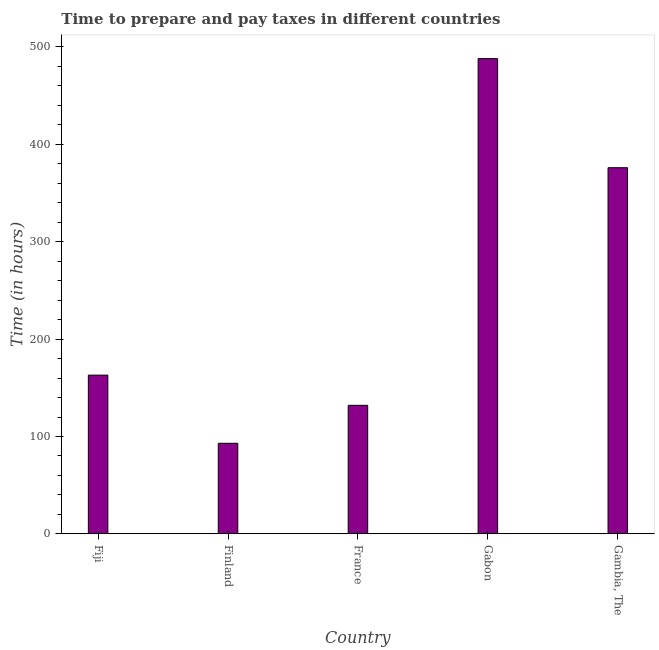Does the graph contain any zero values?
Provide a succinct answer. No. What is the title of the graph?
Provide a succinct answer. Time to prepare and pay taxes in different countries. What is the label or title of the X-axis?
Ensure brevity in your answer.  Country. What is the label or title of the Y-axis?
Your answer should be very brief. Time (in hours). What is the time to prepare and pay taxes in Fiji?
Give a very brief answer. 163. Across all countries, what is the maximum time to prepare and pay taxes?
Offer a very short reply. 488. Across all countries, what is the minimum time to prepare and pay taxes?
Keep it short and to the point. 93. In which country was the time to prepare and pay taxes maximum?
Your response must be concise. Gabon. What is the sum of the time to prepare and pay taxes?
Your answer should be very brief. 1252. What is the difference between the time to prepare and pay taxes in Finland and France?
Your answer should be very brief. -39. What is the average time to prepare and pay taxes per country?
Provide a succinct answer. 250.4. What is the median time to prepare and pay taxes?
Your answer should be very brief. 163. In how many countries, is the time to prepare and pay taxes greater than 100 hours?
Your answer should be very brief. 4. What is the ratio of the time to prepare and pay taxes in Gabon to that in Gambia, The?
Give a very brief answer. 1.3. Is the time to prepare and pay taxes in Fiji less than that in Gabon?
Keep it short and to the point. Yes. Is the difference between the time to prepare and pay taxes in France and Gabon greater than the difference between any two countries?
Offer a very short reply. No. What is the difference between the highest and the second highest time to prepare and pay taxes?
Make the answer very short. 112. Is the sum of the time to prepare and pay taxes in Finland and France greater than the maximum time to prepare and pay taxes across all countries?
Give a very brief answer. No. What is the difference between the highest and the lowest time to prepare and pay taxes?
Your answer should be very brief. 395. In how many countries, is the time to prepare and pay taxes greater than the average time to prepare and pay taxes taken over all countries?
Make the answer very short. 2. How many bars are there?
Provide a short and direct response. 5. How many countries are there in the graph?
Offer a very short reply. 5. What is the difference between two consecutive major ticks on the Y-axis?
Keep it short and to the point. 100. What is the Time (in hours) of Fiji?
Your answer should be compact. 163. What is the Time (in hours) of Finland?
Your answer should be compact. 93. What is the Time (in hours) in France?
Offer a terse response. 132. What is the Time (in hours) in Gabon?
Your answer should be very brief. 488. What is the Time (in hours) of Gambia, The?
Your answer should be compact. 376. What is the difference between the Time (in hours) in Fiji and France?
Provide a succinct answer. 31. What is the difference between the Time (in hours) in Fiji and Gabon?
Provide a succinct answer. -325. What is the difference between the Time (in hours) in Fiji and Gambia, The?
Ensure brevity in your answer.  -213. What is the difference between the Time (in hours) in Finland and France?
Provide a succinct answer. -39. What is the difference between the Time (in hours) in Finland and Gabon?
Ensure brevity in your answer.  -395. What is the difference between the Time (in hours) in Finland and Gambia, The?
Your response must be concise. -283. What is the difference between the Time (in hours) in France and Gabon?
Your answer should be compact. -356. What is the difference between the Time (in hours) in France and Gambia, The?
Your response must be concise. -244. What is the difference between the Time (in hours) in Gabon and Gambia, The?
Your response must be concise. 112. What is the ratio of the Time (in hours) in Fiji to that in Finland?
Ensure brevity in your answer.  1.75. What is the ratio of the Time (in hours) in Fiji to that in France?
Your response must be concise. 1.24. What is the ratio of the Time (in hours) in Fiji to that in Gabon?
Offer a terse response. 0.33. What is the ratio of the Time (in hours) in Fiji to that in Gambia, The?
Provide a succinct answer. 0.43. What is the ratio of the Time (in hours) in Finland to that in France?
Ensure brevity in your answer.  0.7. What is the ratio of the Time (in hours) in Finland to that in Gabon?
Your response must be concise. 0.19. What is the ratio of the Time (in hours) in Finland to that in Gambia, The?
Your answer should be compact. 0.25. What is the ratio of the Time (in hours) in France to that in Gabon?
Offer a very short reply. 0.27. What is the ratio of the Time (in hours) in France to that in Gambia, The?
Offer a very short reply. 0.35. What is the ratio of the Time (in hours) in Gabon to that in Gambia, The?
Offer a very short reply. 1.3. 